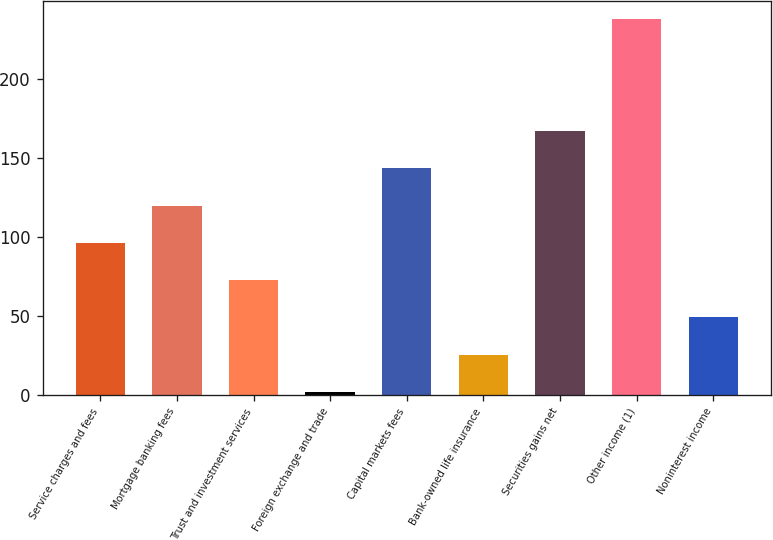Convert chart. <chart><loc_0><loc_0><loc_500><loc_500><bar_chart><fcel>Service charges and fees<fcel>Mortgage banking fees<fcel>Trust and investment services<fcel>Foreign exchange and trade<fcel>Capital markets fees<fcel>Bank-owned life insurance<fcel>Securities gains net<fcel>Other income (1)<fcel>Noninterest income<nl><fcel>96.4<fcel>120<fcel>72.8<fcel>2<fcel>143.6<fcel>25.6<fcel>167.2<fcel>238<fcel>49.2<nl></chart> 